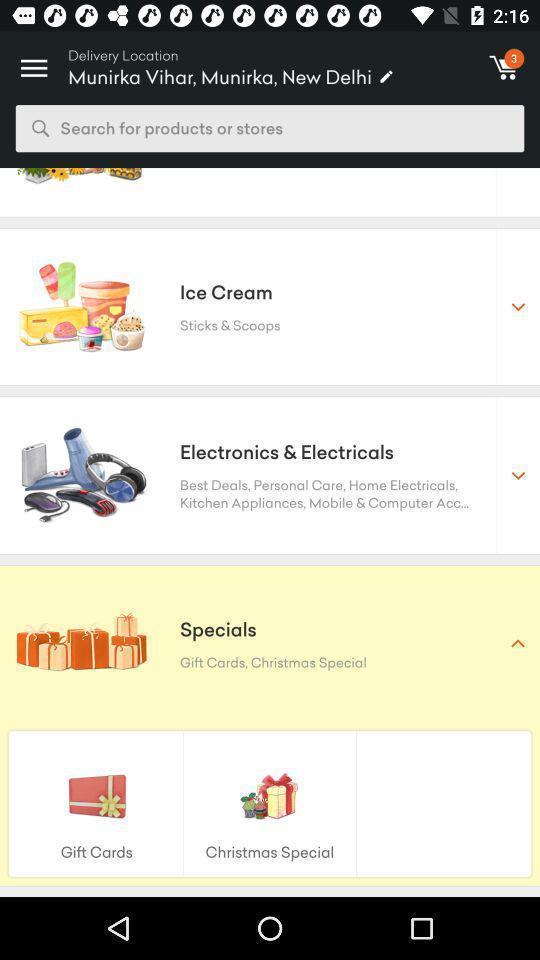Describe the content in this image. Screen displaying the list of categories. 